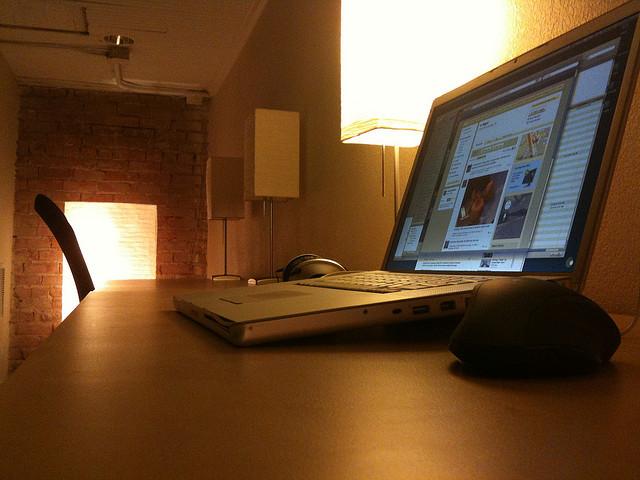Is the screen locked?
Quick response, please. No. What brand of mouse is on the desk?
Give a very brief answer. Apple. Is the a lamp on the wall?
Quick response, please. Yes. What is the laptop resting on?
Write a very short answer. Desk. 